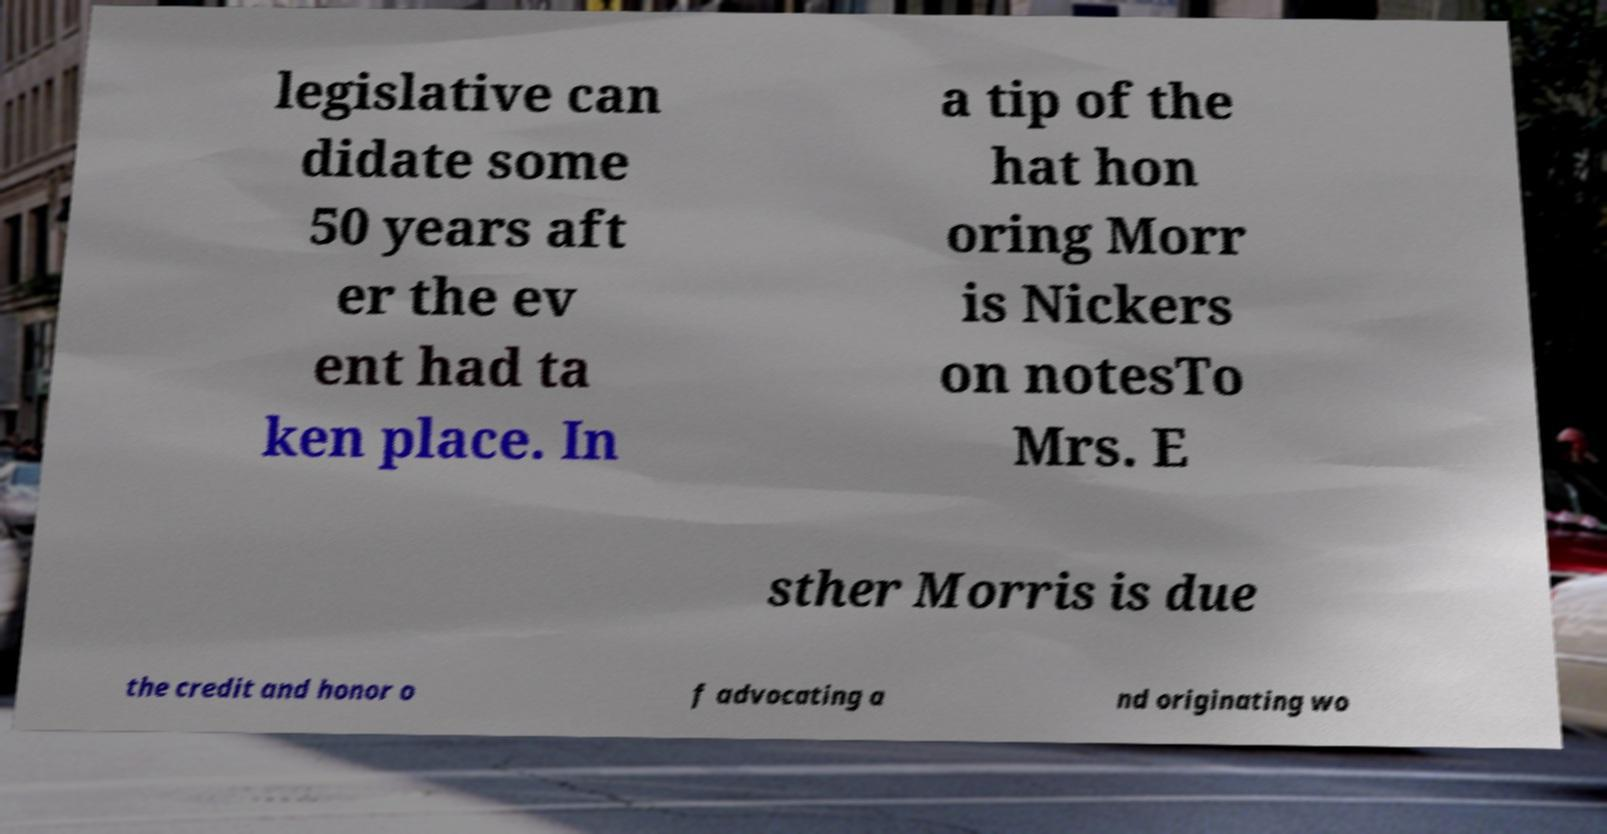What messages or text are displayed in this image? I need them in a readable, typed format. legislative can didate some 50 years aft er the ev ent had ta ken place. In a tip of the hat hon oring Morr is Nickers on notesTo Mrs. E sther Morris is due the credit and honor o f advocating a nd originating wo 